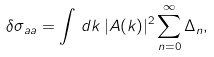<formula> <loc_0><loc_0><loc_500><loc_500>\delta \sigma _ { a a } = \int \, d k \, | A ( k ) | ^ { 2 } \sum _ { n = 0 } ^ { \infty } \Delta _ { n } ,</formula> 